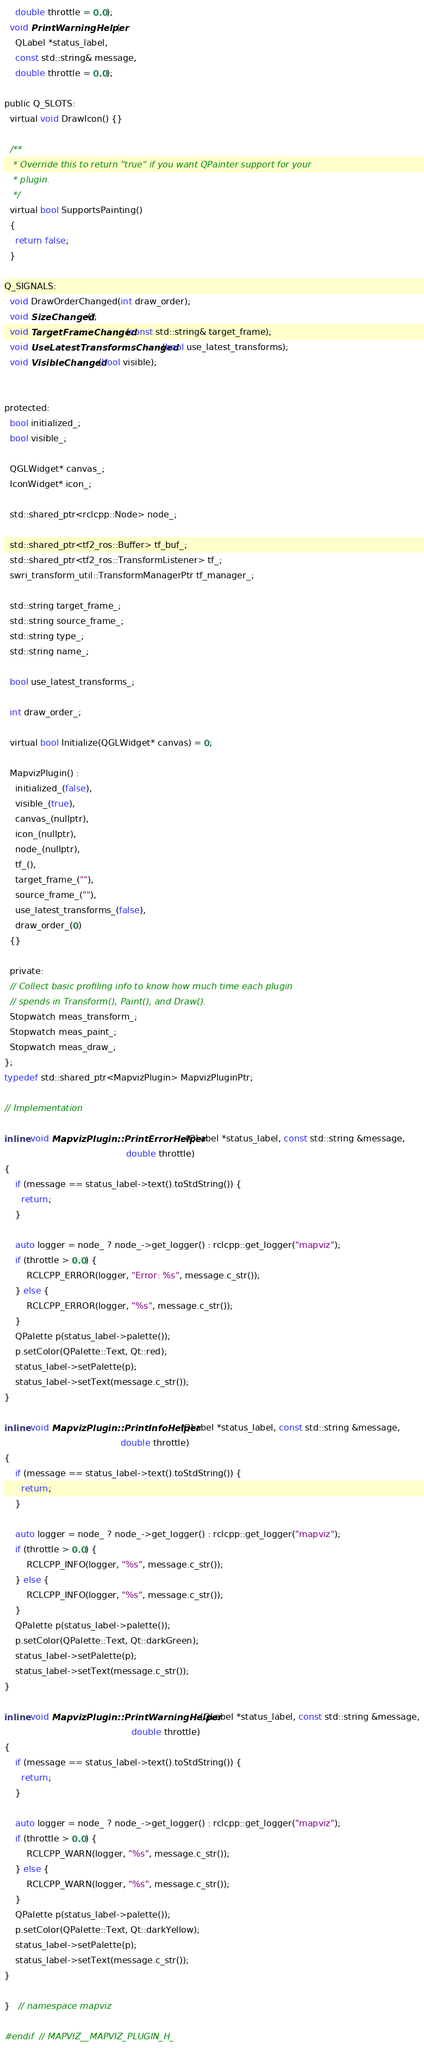<code> <loc_0><loc_0><loc_500><loc_500><_C_>    double throttle = 0.0);
  void PrintWarningHelper(
    QLabel *status_label,
    const std::string& message,
    double throttle = 0.0);

public Q_SLOTS:
  virtual void DrawIcon() {}

  /**
   * Override this to return "true" if you want QPainter support for your
   * plugin.
   */
  virtual bool SupportsPainting()
  {
    return false;
  }

Q_SIGNALS:
  void DrawOrderChanged(int draw_order);
  void SizeChanged();
  void TargetFrameChanged(const std::string& target_frame);
  void UseLatestTransformsChanged(bool use_latest_transforms);
  void VisibleChanged(bool visible);


protected:
  bool initialized_;
  bool visible_;

  QGLWidget* canvas_;
  IconWidget* icon_;

  std::shared_ptr<rclcpp::Node> node_;

  std::shared_ptr<tf2_ros::Buffer> tf_buf_;
  std::shared_ptr<tf2_ros::TransformListener> tf_;
  swri_transform_util::TransformManagerPtr tf_manager_;

  std::string target_frame_;
  std::string source_frame_;
  std::string type_;
  std::string name_;

  bool use_latest_transforms_;

  int draw_order_;

  virtual bool Initialize(QGLWidget* canvas) = 0;

  MapvizPlugin() :
    initialized_(false),
    visible_(true),
    canvas_(nullptr),
    icon_(nullptr),
    node_(nullptr),
    tf_(),
    target_frame_(""),
    source_frame_(""),
    use_latest_transforms_(false),
    draw_order_(0)
  {}

  private:
  // Collect basic profiling info to know how much time each plugin
  // spends in Transform(), Paint(), and Draw().
  Stopwatch meas_transform_;
  Stopwatch meas_paint_;
  Stopwatch meas_draw_;
};
typedef std::shared_ptr<MapvizPlugin> MapvizPluginPtr;

// Implementation

inline void MapvizPlugin::PrintErrorHelper(QLabel *status_label, const std::string &message,
                                            double throttle)
{
    if (message == status_label->text().toStdString()) {
      return;
    }

    auto logger = node_ ? node_->get_logger() : rclcpp::get_logger("mapviz");
    if (throttle > 0.0) {
        RCLCPP_ERROR(logger, "Error: %s", message.c_str());
    } else {
        RCLCPP_ERROR(logger, "%s", message.c_str());
    }
    QPalette p(status_label->palette());
    p.setColor(QPalette::Text, Qt::red);
    status_label->setPalette(p);
    status_label->setText(message.c_str());
}

inline void MapvizPlugin::PrintInfoHelper(QLabel *status_label, const std::string &message,
                                          double throttle)
{
    if (message == status_label->text().toStdString()) {
      return;
    }

    auto logger = node_ ? node_->get_logger() : rclcpp::get_logger("mapviz");
    if (throttle > 0.0) {
        RCLCPP_INFO(logger, "%s", message.c_str());
    } else {
        RCLCPP_INFO(logger, "%s", message.c_str());
    }
    QPalette p(status_label->palette());
    p.setColor(QPalette::Text, Qt::darkGreen);
    status_label->setPalette(p);
    status_label->setText(message.c_str());
}

inline void MapvizPlugin::PrintWarningHelper(QLabel *status_label, const std::string &message,
                                              double throttle)
{
    if (message == status_label->text().toStdString()) {
      return;
    }

    auto logger = node_ ? node_->get_logger() : rclcpp::get_logger("mapviz");
    if (throttle > 0.0) {
        RCLCPP_WARN(logger, "%s", message.c_str());
    } else {
        RCLCPP_WARN(logger, "%s", message.c_str());
    }
    QPalette p(status_label->palette());
    p.setColor(QPalette::Text, Qt::darkYellow);
    status_label->setPalette(p);
    status_label->setText(message.c_str());
}

}   // namespace mapviz

#endif  // MAPVIZ__MAPVIZ_PLUGIN_H_

</code> 